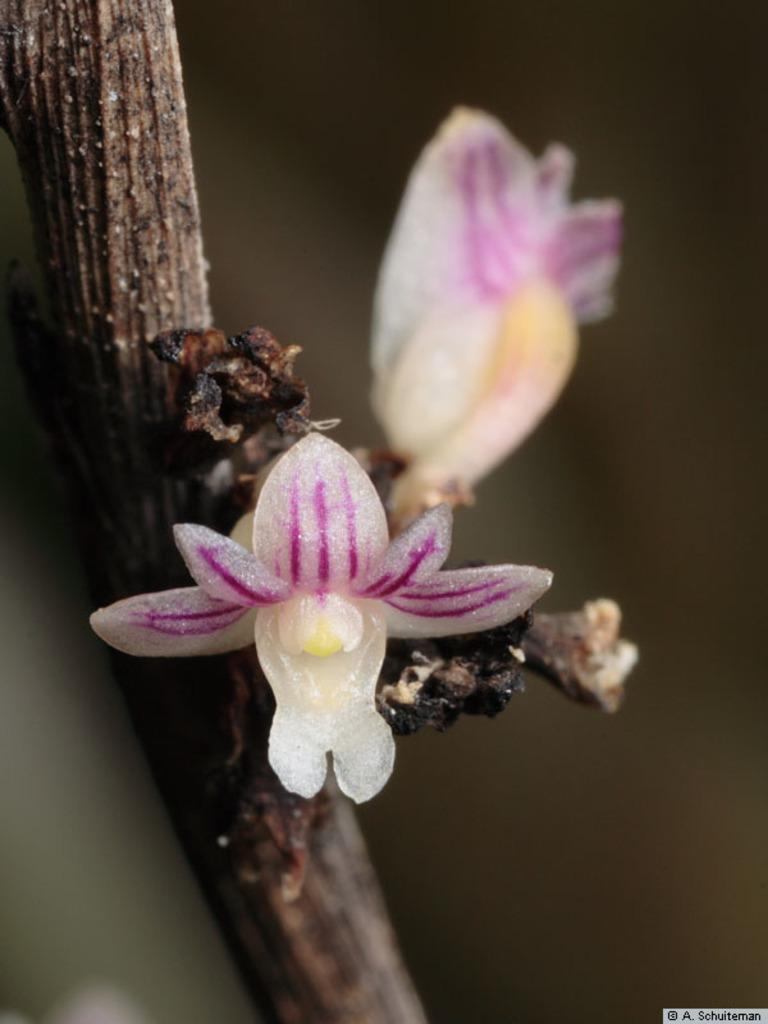What is the main subject of the image? The main subject of the image is a flower. Can you describe the colors of the flower? The flower has white and pink colors. Where is the flower located in the image? The flower is on a branch. What is the color of the background in the image? The background of the image is dark. How many brothers are depicted in the image? There are no brothers present in the image; it features a flower on a branch with a dark background. What type of egg can be seen in the image? There is no egg present in the image. 